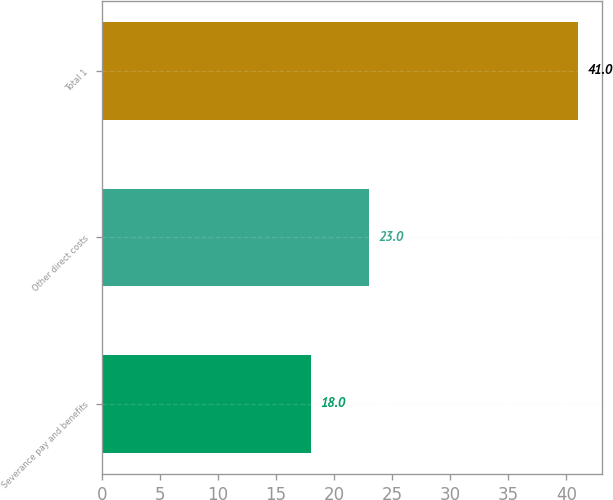Convert chart to OTSL. <chart><loc_0><loc_0><loc_500><loc_500><bar_chart><fcel>Severance pay and benefits<fcel>Other direct costs<fcel>Total 1<nl><fcel>18<fcel>23<fcel>41<nl></chart> 